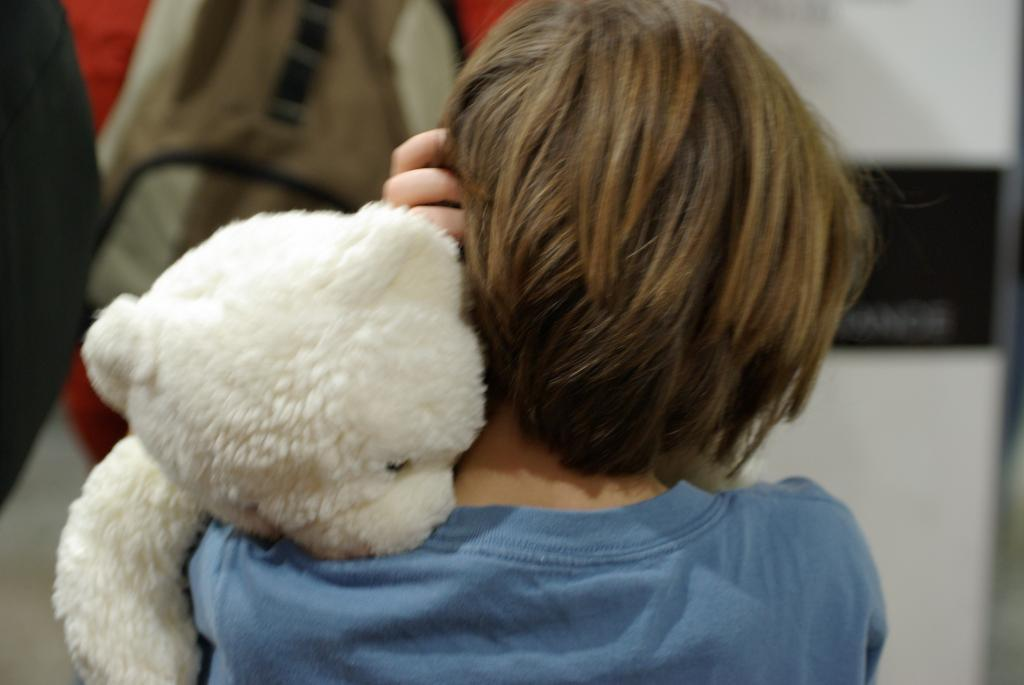Who is the main subject in the image? There is a small boy in the image. Where is the boy positioned in the image? The boy is in the center of the image. What is the boy holding in his hands? The boy is holding a teddy bear in his hands. How many sheep can be seen in the market in the image? There are no sheep or market present in the image; it features a small boy holding a teddy bear. 